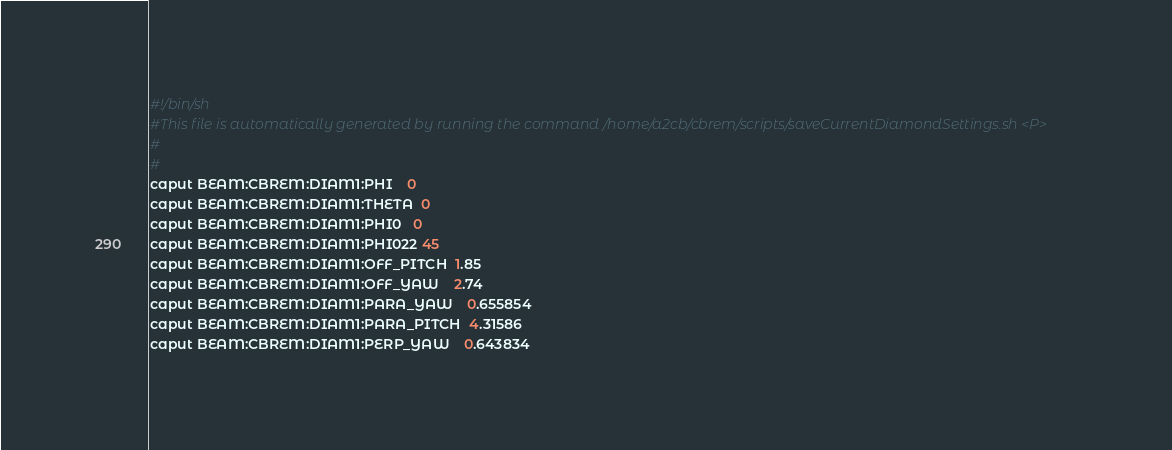<code> <loc_0><loc_0><loc_500><loc_500><_Bash_>#!/bin/sh
#This file is automatically generated by running the command /home/a2cb/cbrem/scripts/saveCurrentDiamondSettings.sh <P>
#
#
caput BEAM:CBREM:DIAM1:PHI    0
caput BEAM:CBREM:DIAM1:THETA  0
caput BEAM:CBREM:DIAM1:PHI0   0
caput BEAM:CBREM:DIAM1:PHI022 45
caput BEAM:CBREM:DIAM1:OFF_PITCH  1.85
caput BEAM:CBREM:DIAM1:OFF_YAW    2.74
caput BEAM:CBREM:DIAM1:PARA_YAW    0.655854
caput BEAM:CBREM:DIAM1:PARA_PITCH  4.31586
caput BEAM:CBREM:DIAM1:PERP_YAW    0.643834</code> 